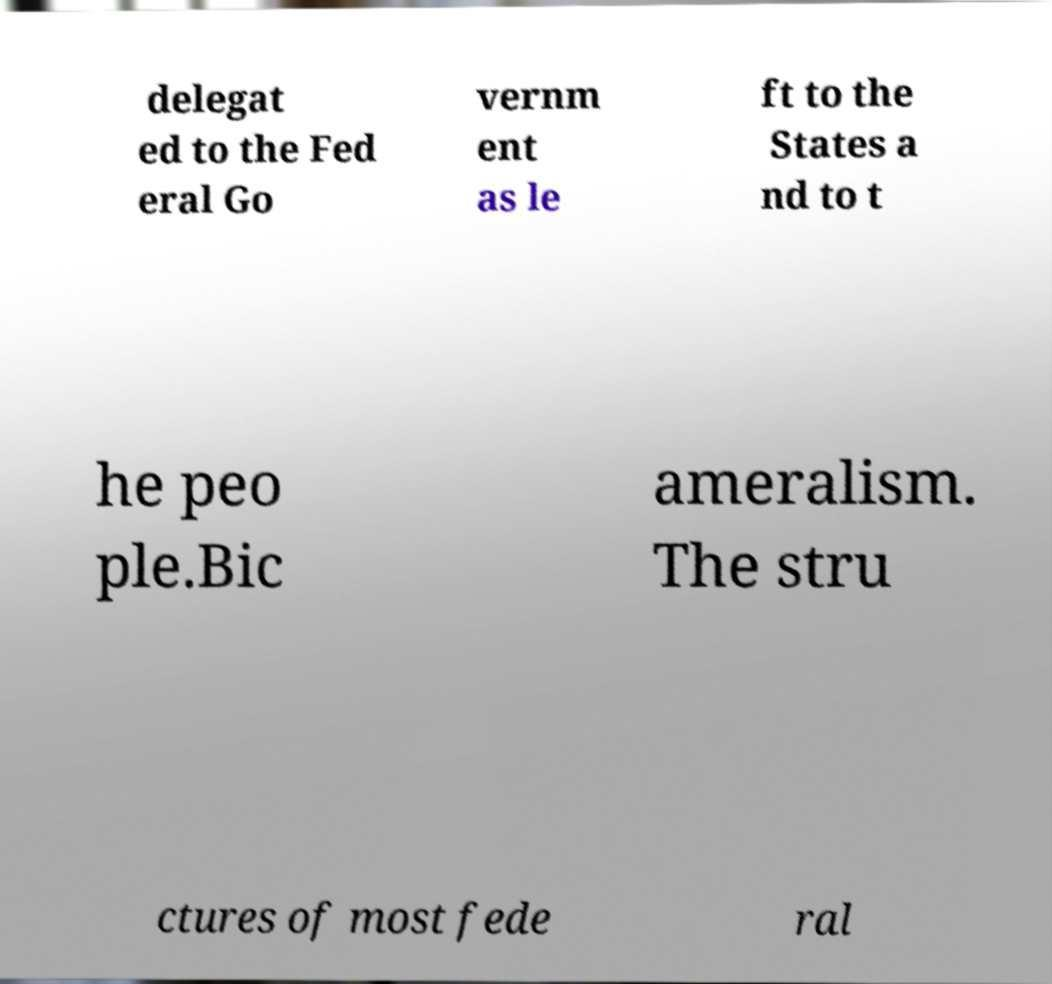Could you assist in decoding the text presented in this image and type it out clearly? delegat ed to the Fed eral Go vernm ent as le ft to the States a nd to t he peo ple.Bic ameralism. The stru ctures of most fede ral 